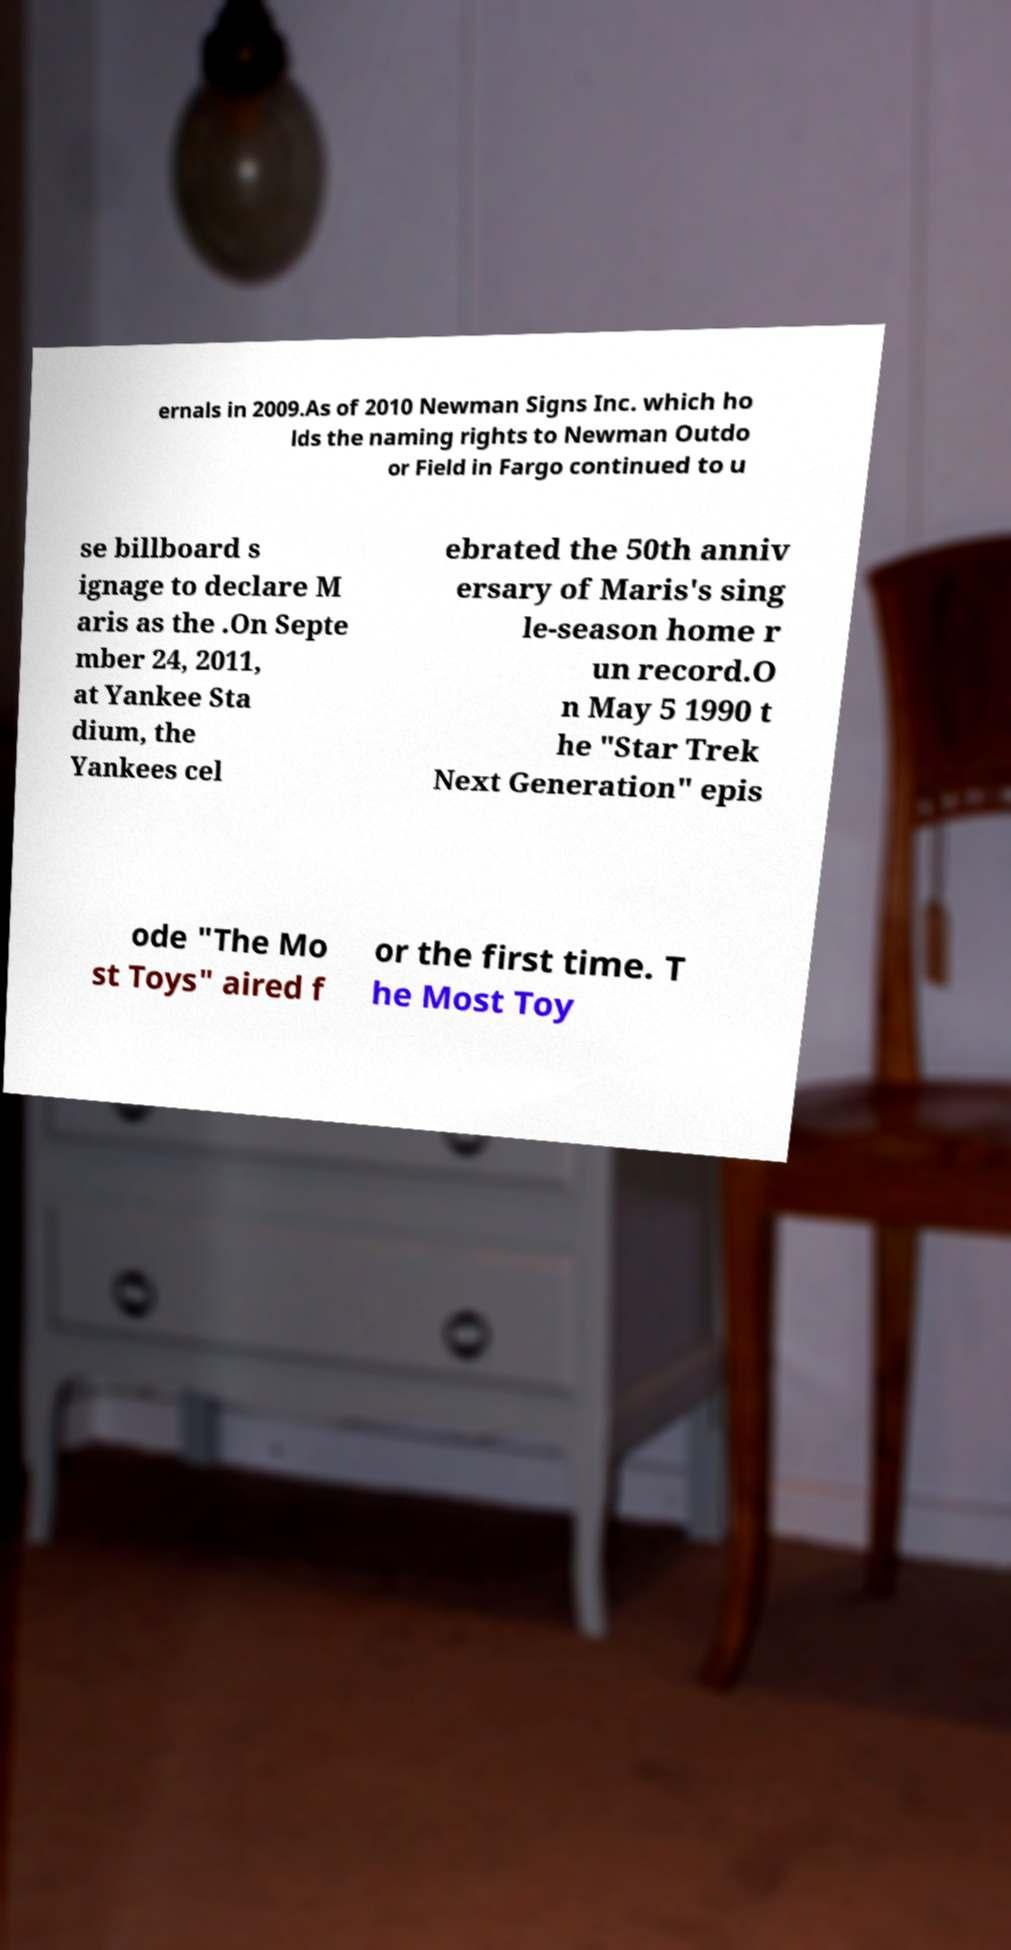I need the written content from this picture converted into text. Can you do that? ernals in 2009.As of 2010 Newman Signs Inc. which ho lds the naming rights to Newman Outdo or Field in Fargo continued to u se billboard s ignage to declare M aris as the .On Septe mber 24, 2011, at Yankee Sta dium, the Yankees cel ebrated the 50th anniv ersary of Maris's sing le-season home r un record.O n May 5 1990 t he "Star Trek Next Generation" epis ode "The Mo st Toys" aired f or the first time. T he Most Toy 